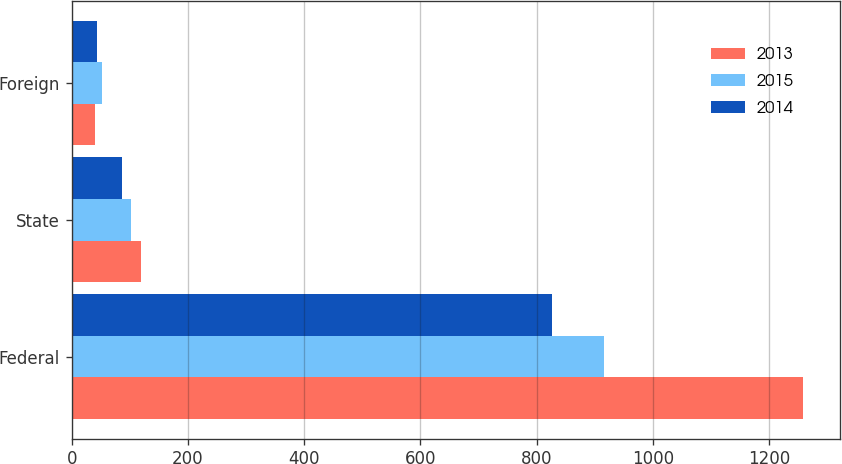Convert chart to OTSL. <chart><loc_0><loc_0><loc_500><loc_500><stacked_bar_chart><ecel><fcel>Federal<fcel>State<fcel>Foreign<nl><fcel>2013<fcel>1259<fcel>119<fcel>40<nl><fcel>2015<fcel>916<fcel>102<fcel>52<nl><fcel>2014<fcel>827<fcel>86<fcel>44<nl></chart> 